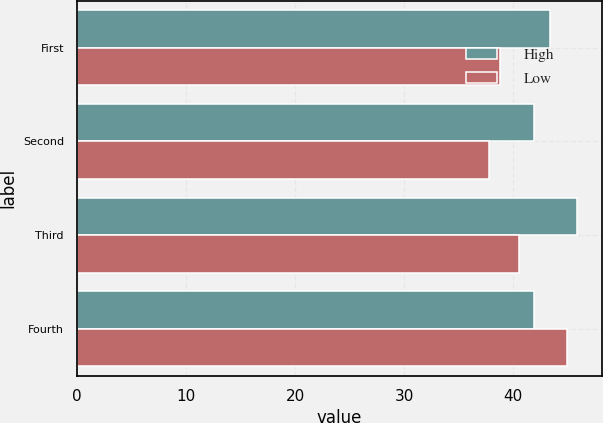Convert chart to OTSL. <chart><loc_0><loc_0><loc_500><loc_500><stacked_bar_chart><ecel><fcel>First<fcel>Second<fcel>Third<fcel>Fourth<nl><fcel>High<fcel>43.42<fcel>41.97<fcel>45.87<fcel>41.97<nl><fcel>Low<fcel>38.85<fcel>37.81<fcel>40.59<fcel>44.97<nl></chart> 